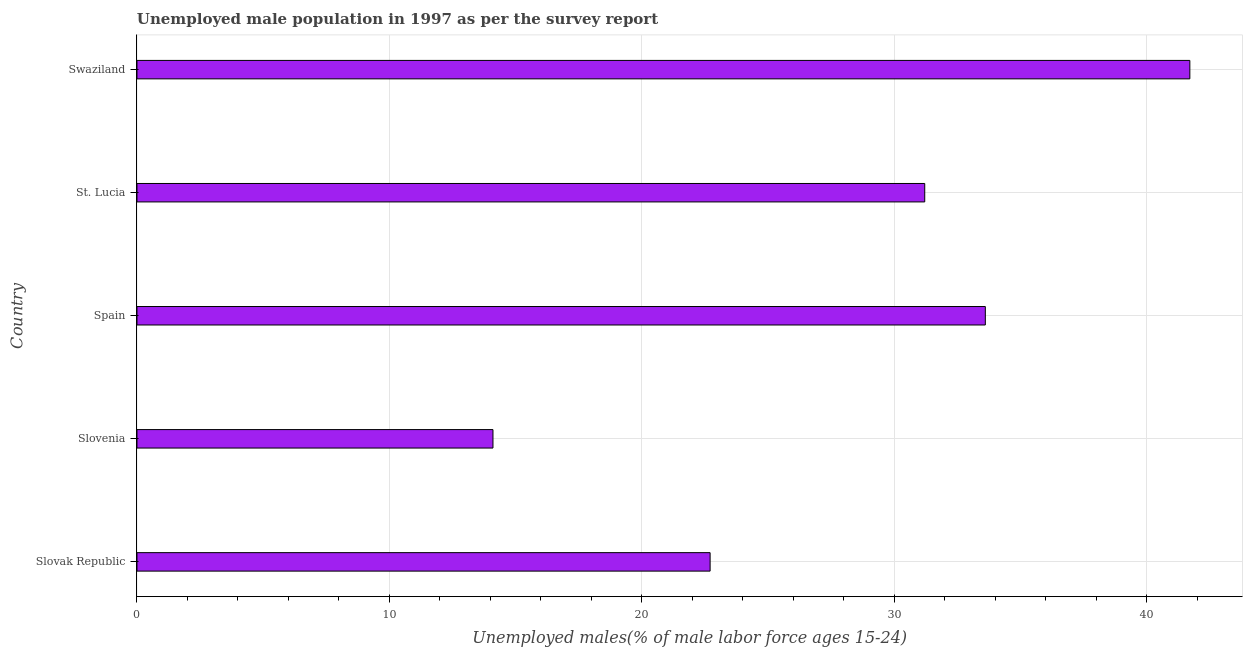Does the graph contain any zero values?
Provide a short and direct response. No. Does the graph contain grids?
Provide a short and direct response. Yes. What is the title of the graph?
Ensure brevity in your answer.  Unemployed male population in 1997 as per the survey report. What is the label or title of the X-axis?
Offer a very short reply. Unemployed males(% of male labor force ages 15-24). What is the label or title of the Y-axis?
Provide a succinct answer. Country. What is the unemployed male youth in Swaziland?
Make the answer very short. 41.7. Across all countries, what is the maximum unemployed male youth?
Your response must be concise. 41.7. Across all countries, what is the minimum unemployed male youth?
Offer a terse response. 14.1. In which country was the unemployed male youth maximum?
Ensure brevity in your answer.  Swaziland. In which country was the unemployed male youth minimum?
Provide a succinct answer. Slovenia. What is the sum of the unemployed male youth?
Your answer should be compact. 143.3. What is the average unemployed male youth per country?
Your answer should be very brief. 28.66. What is the median unemployed male youth?
Give a very brief answer. 31.2. What is the ratio of the unemployed male youth in St. Lucia to that in Swaziland?
Your response must be concise. 0.75. Is the unemployed male youth in Slovak Republic less than that in Slovenia?
Your response must be concise. No. Is the difference between the unemployed male youth in Slovenia and Swaziland greater than the difference between any two countries?
Offer a very short reply. Yes. What is the difference between the highest and the lowest unemployed male youth?
Provide a succinct answer. 27.6. In how many countries, is the unemployed male youth greater than the average unemployed male youth taken over all countries?
Make the answer very short. 3. How many countries are there in the graph?
Ensure brevity in your answer.  5. What is the Unemployed males(% of male labor force ages 15-24) in Slovak Republic?
Your answer should be compact. 22.7. What is the Unemployed males(% of male labor force ages 15-24) of Slovenia?
Keep it short and to the point. 14.1. What is the Unemployed males(% of male labor force ages 15-24) in Spain?
Offer a very short reply. 33.6. What is the Unemployed males(% of male labor force ages 15-24) in St. Lucia?
Provide a succinct answer. 31.2. What is the Unemployed males(% of male labor force ages 15-24) in Swaziland?
Keep it short and to the point. 41.7. What is the difference between the Unemployed males(% of male labor force ages 15-24) in Slovak Republic and Slovenia?
Your response must be concise. 8.6. What is the difference between the Unemployed males(% of male labor force ages 15-24) in Slovak Republic and St. Lucia?
Give a very brief answer. -8.5. What is the difference between the Unemployed males(% of male labor force ages 15-24) in Slovak Republic and Swaziland?
Offer a terse response. -19. What is the difference between the Unemployed males(% of male labor force ages 15-24) in Slovenia and Spain?
Your response must be concise. -19.5. What is the difference between the Unemployed males(% of male labor force ages 15-24) in Slovenia and St. Lucia?
Offer a terse response. -17.1. What is the difference between the Unemployed males(% of male labor force ages 15-24) in Slovenia and Swaziland?
Provide a short and direct response. -27.6. What is the difference between the Unemployed males(% of male labor force ages 15-24) in Spain and St. Lucia?
Make the answer very short. 2.4. What is the ratio of the Unemployed males(% of male labor force ages 15-24) in Slovak Republic to that in Slovenia?
Give a very brief answer. 1.61. What is the ratio of the Unemployed males(% of male labor force ages 15-24) in Slovak Republic to that in Spain?
Ensure brevity in your answer.  0.68. What is the ratio of the Unemployed males(% of male labor force ages 15-24) in Slovak Republic to that in St. Lucia?
Your answer should be very brief. 0.73. What is the ratio of the Unemployed males(% of male labor force ages 15-24) in Slovak Republic to that in Swaziland?
Offer a terse response. 0.54. What is the ratio of the Unemployed males(% of male labor force ages 15-24) in Slovenia to that in Spain?
Offer a terse response. 0.42. What is the ratio of the Unemployed males(% of male labor force ages 15-24) in Slovenia to that in St. Lucia?
Make the answer very short. 0.45. What is the ratio of the Unemployed males(% of male labor force ages 15-24) in Slovenia to that in Swaziland?
Your answer should be very brief. 0.34. What is the ratio of the Unemployed males(% of male labor force ages 15-24) in Spain to that in St. Lucia?
Your answer should be very brief. 1.08. What is the ratio of the Unemployed males(% of male labor force ages 15-24) in Spain to that in Swaziland?
Make the answer very short. 0.81. What is the ratio of the Unemployed males(% of male labor force ages 15-24) in St. Lucia to that in Swaziland?
Provide a short and direct response. 0.75. 